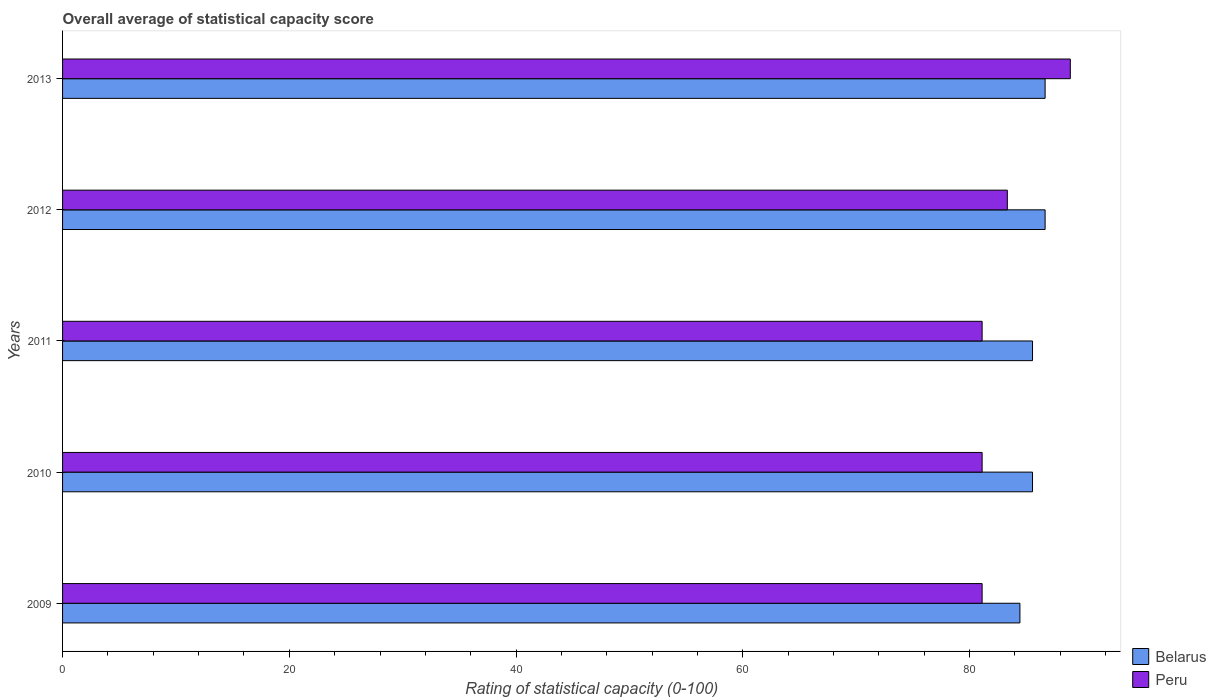How many different coloured bars are there?
Provide a short and direct response. 2. How many groups of bars are there?
Provide a succinct answer. 5. Are the number of bars on each tick of the Y-axis equal?
Offer a terse response. Yes. How many bars are there on the 2nd tick from the top?
Keep it short and to the point. 2. How many bars are there on the 3rd tick from the bottom?
Keep it short and to the point. 2. What is the rating of statistical capacity in Peru in 2013?
Your response must be concise. 88.89. Across all years, what is the maximum rating of statistical capacity in Peru?
Your response must be concise. 88.89. Across all years, what is the minimum rating of statistical capacity in Peru?
Keep it short and to the point. 81.11. In which year was the rating of statistical capacity in Peru maximum?
Your answer should be compact. 2013. In which year was the rating of statistical capacity in Peru minimum?
Provide a succinct answer. 2009. What is the total rating of statistical capacity in Peru in the graph?
Your answer should be very brief. 415.56. What is the difference between the rating of statistical capacity in Peru in 2009 and that in 2013?
Offer a very short reply. -7.78. What is the difference between the rating of statistical capacity in Peru in 2011 and the rating of statistical capacity in Belarus in 2013?
Offer a terse response. -5.56. What is the average rating of statistical capacity in Peru per year?
Provide a short and direct response. 83.11. In the year 2012, what is the difference between the rating of statistical capacity in Belarus and rating of statistical capacity in Peru?
Keep it short and to the point. 3.33. What is the ratio of the rating of statistical capacity in Peru in 2009 to that in 2011?
Provide a short and direct response. 1. Is the rating of statistical capacity in Belarus in 2011 less than that in 2013?
Your response must be concise. Yes. What is the difference between the highest and the second highest rating of statistical capacity in Peru?
Provide a succinct answer. 5.56. What is the difference between the highest and the lowest rating of statistical capacity in Belarus?
Provide a succinct answer. 2.22. What does the 2nd bar from the top in 2011 represents?
Offer a terse response. Belarus. What does the 2nd bar from the bottom in 2011 represents?
Your answer should be very brief. Peru. How many years are there in the graph?
Keep it short and to the point. 5. Does the graph contain any zero values?
Keep it short and to the point. No. How many legend labels are there?
Ensure brevity in your answer.  2. How are the legend labels stacked?
Give a very brief answer. Vertical. What is the title of the graph?
Make the answer very short. Overall average of statistical capacity score. What is the label or title of the X-axis?
Ensure brevity in your answer.  Rating of statistical capacity (0-100). What is the Rating of statistical capacity (0-100) in Belarus in 2009?
Provide a succinct answer. 84.44. What is the Rating of statistical capacity (0-100) of Peru in 2009?
Provide a short and direct response. 81.11. What is the Rating of statistical capacity (0-100) in Belarus in 2010?
Provide a succinct answer. 85.56. What is the Rating of statistical capacity (0-100) in Peru in 2010?
Ensure brevity in your answer.  81.11. What is the Rating of statistical capacity (0-100) in Belarus in 2011?
Keep it short and to the point. 85.56. What is the Rating of statistical capacity (0-100) of Peru in 2011?
Make the answer very short. 81.11. What is the Rating of statistical capacity (0-100) in Belarus in 2012?
Keep it short and to the point. 86.67. What is the Rating of statistical capacity (0-100) of Peru in 2012?
Keep it short and to the point. 83.33. What is the Rating of statistical capacity (0-100) in Belarus in 2013?
Provide a succinct answer. 86.67. What is the Rating of statistical capacity (0-100) in Peru in 2013?
Keep it short and to the point. 88.89. Across all years, what is the maximum Rating of statistical capacity (0-100) of Belarus?
Your response must be concise. 86.67. Across all years, what is the maximum Rating of statistical capacity (0-100) of Peru?
Keep it short and to the point. 88.89. Across all years, what is the minimum Rating of statistical capacity (0-100) of Belarus?
Your response must be concise. 84.44. Across all years, what is the minimum Rating of statistical capacity (0-100) of Peru?
Offer a very short reply. 81.11. What is the total Rating of statistical capacity (0-100) in Belarus in the graph?
Provide a short and direct response. 428.89. What is the total Rating of statistical capacity (0-100) in Peru in the graph?
Offer a terse response. 415.56. What is the difference between the Rating of statistical capacity (0-100) in Belarus in 2009 and that in 2010?
Provide a succinct answer. -1.11. What is the difference between the Rating of statistical capacity (0-100) in Peru in 2009 and that in 2010?
Your answer should be compact. 0. What is the difference between the Rating of statistical capacity (0-100) of Belarus in 2009 and that in 2011?
Make the answer very short. -1.11. What is the difference between the Rating of statistical capacity (0-100) in Belarus in 2009 and that in 2012?
Your response must be concise. -2.22. What is the difference between the Rating of statistical capacity (0-100) of Peru in 2009 and that in 2012?
Your answer should be very brief. -2.22. What is the difference between the Rating of statistical capacity (0-100) in Belarus in 2009 and that in 2013?
Make the answer very short. -2.22. What is the difference between the Rating of statistical capacity (0-100) of Peru in 2009 and that in 2013?
Your answer should be very brief. -7.78. What is the difference between the Rating of statistical capacity (0-100) in Belarus in 2010 and that in 2011?
Keep it short and to the point. 0. What is the difference between the Rating of statistical capacity (0-100) of Belarus in 2010 and that in 2012?
Keep it short and to the point. -1.11. What is the difference between the Rating of statistical capacity (0-100) of Peru in 2010 and that in 2012?
Your response must be concise. -2.22. What is the difference between the Rating of statistical capacity (0-100) in Belarus in 2010 and that in 2013?
Provide a short and direct response. -1.11. What is the difference between the Rating of statistical capacity (0-100) in Peru in 2010 and that in 2013?
Your answer should be compact. -7.78. What is the difference between the Rating of statistical capacity (0-100) in Belarus in 2011 and that in 2012?
Your answer should be compact. -1.11. What is the difference between the Rating of statistical capacity (0-100) of Peru in 2011 and that in 2012?
Provide a short and direct response. -2.22. What is the difference between the Rating of statistical capacity (0-100) of Belarus in 2011 and that in 2013?
Give a very brief answer. -1.11. What is the difference between the Rating of statistical capacity (0-100) in Peru in 2011 and that in 2013?
Make the answer very short. -7.78. What is the difference between the Rating of statistical capacity (0-100) of Peru in 2012 and that in 2013?
Provide a succinct answer. -5.56. What is the difference between the Rating of statistical capacity (0-100) in Belarus in 2009 and the Rating of statistical capacity (0-100) in Peru in 2013?
Offer a terse response. -4.44. What is the difference between the Rating of statistical capacity (0-100) of Belarus in 2010 and the Rating of statistical capacity (0-100) of Peru in 2011?
Offer a terse response. 4.44. What is the difference between the Rating of statistical capacity (0-100) in Belarus in 2010 and the Rating of statistical capacity (0-100) in Peru in 2012?
Provide a short and direct response. 2.22. What is the difference between the Rating of statistical capacity (0-100) in Belarus in 2010 and the Rating of statistical capacity (0-100) in Peru in 2013?
Give a very brief answer. -3.33. What is the difference between the Rating of statistical capacity (0-100) in Belarus in 2011 and the Rating of statistical capacity (0-100) in Peru in 2012?
Ensure brevity in your answer.  2.22. What is the difference between the Rating of statistical capacity (0-100) of Belarus in 2012 and the Rating of statistical capacity (0-100) of Peru in 2013?
Provide a succinct answer. -2.22. What is the average Rating of statistical capacity (0-100) of Belarus per year?
Keep it short and to the point. 85.78. What is the average Rating of statistical capacity (0-100) in Peru per year?
Give a very brief answer. 83.11. In the year 2010, what is the difference between the Rating of statistical capacity (0-100) of Belarus and Rating of statistical capacity (0-100) of Peru?
Provide a succinct answer. 4.44. In the year 2011, what is the difference between the Rating of statistical capacity (0-100) in Belarus and Rating of statistical capacity (0-100) in Peru?
Your answer should be compact. 4.44. In the year 2013, what is the difference between the Rating of statistical capacity (0-100) in Belarus and Rating of statistical capacity (0-100) in Peru?
Ensure brevity in your answer.  -2.22. What is the ratio of the Rating of statistical capacity (0-100) of Belarus in 2009 to that in 2010?
Give a very brief answer. 0.99. What is the ratio of the Rating of statistical capacity (0-100) of Peru in 2009 to that in 2010?
Your answer should be very brief. 1. What is the ratio of the Rating of statistical capacity (0-100) in Belarus in 2009 to that in 2011?
Provide a short and direct response. 0.99. What is the ratio of the Rating of statistical capacity (0-100) of Peru in 2009 to that in 2011?
Give a very brief answer. 1. What is the ratio of the Rating of statistical capacity (0-100) of Belarus in 2009 to that in 2012?
Offer a terse response. 0.97. What is the ratio of the Rating of statistical capacity (0-100) of Peru in 2009 to that in 2012?
Offer a terse response. 0.97. What is the ratio of the Rating of statistical capacity (0-100) of Belarus in 2009 to that in 2013?
Offer a very short reply. 0.97. What is the ratio of the Rating of statistical capacity (0-100) in Peru in 2009 to that in 2013?
Offer a very short reply. 0.91. What is the ratio of the Rating of statistical capacity (0-100) of Belarus in 2010 to that in 2011?
Your answer should be very brief. 1. What is the ratio of the Rating of statistical capacity (0-100) in Peru in 2010 to that in 2011?
Keep it short and to the point. 1. What is the ratio of the Rating of statistical capacity (0-100) in Belarus in 2010 to that in 2012?
Offer a terse response. 0.99. What is the ratio of the Rating of statistical capacity (0-100) in Peru in 2010 to that in 2012?
Offer a terse response. 0.97. What is the ratio of the Rating of statistical capacity (0-100) of Belarus in 2010 to that in 2013?
Make the answer very short. 0.99. What is the ratio of the Rating of statistical capacity (0-100) of Peru in 2010 to that in 2013?
Offer a terse response. 0.91. What is the ratio of the Rating of statistical capacity (0-100) of Belarus in 2011 to that in 2012?
Provide a short and direct response. 0.99. What is the ratio of the Rating of statistical capacity (0-100) in Peru in 2011 to that in 2012?
Your response must be concise. 0.97. What is the ratio of the Rating of statistical capacity (0-100) of Belarus in 2011 to that in 2013?
Give a very brief answer. 0.99. What is the ratio of the Rating of statistical capacity (0-100) in Peru in 2011 to that in 2013?
Provide a succinct answer. 0.91. What is the ratio of the Rating of statistical capacity (0-100) in Peru in 2012 to that in 2013?
Your answer should be very brief. 0.94. What is the difference between the highest and the second highest Rating of statistical capacity (0-100) of Belarus?
Ensure brevity in your answer.  0. What is the difference between the highest and the second highest Rating of statistical capacity (0-100) of Peru?
Provide a succinct answer. 5.56. What is the difference between the highest and the lowest Rating of statistical capacity (0-100) in Belarus?
Your response must be concise. 2.22. What is the difference between the highest and the lowest Rating of statistical capacity (0-100) in Peru?
Your answer should be very brief. 7.78. 